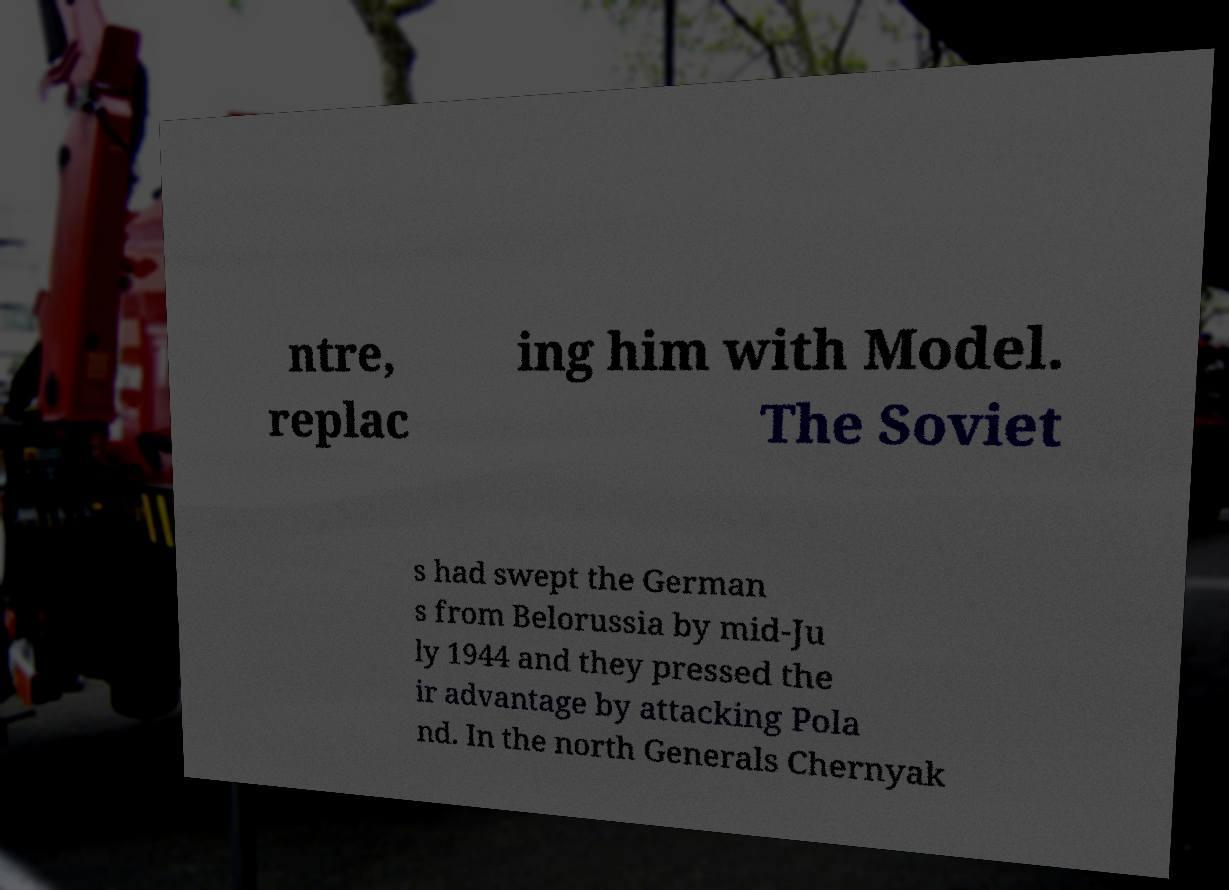Please read and relay the text visible in this image. What does it say? ntre, replac ing him with Model. The Soviet s had swept the German s from Belorussia by mid-Ju ly 1944 and they pressed the ir advantage by attacking Pola nd. In the north Generals Chernyak 